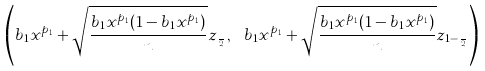Convert formula to latex. <formula><loc_0><loc_0><loc_500><loc_500>\left ( b _ { 1 } x ^ { p _ { 1 } } + \sqrt { \frac { b _ { 1 } x ^ { p _ { 1 } } ( 1 - b _ { 1 } x ^ { p _ { 1 } } ) } { n } } z _ { \frac { \alpha } { 2 } } , \ b _ { 1 } x ^ { p _ { 1 } } + \sqrt { \frac { b _ { 1 } x ^ { p _ { 1 } } ( 1 - b _ { 1 } x ^ { p _ { 1 } } ) } { n } } z _ { 1 - \frac { \alpha } { 2 } } \right )</formula> 